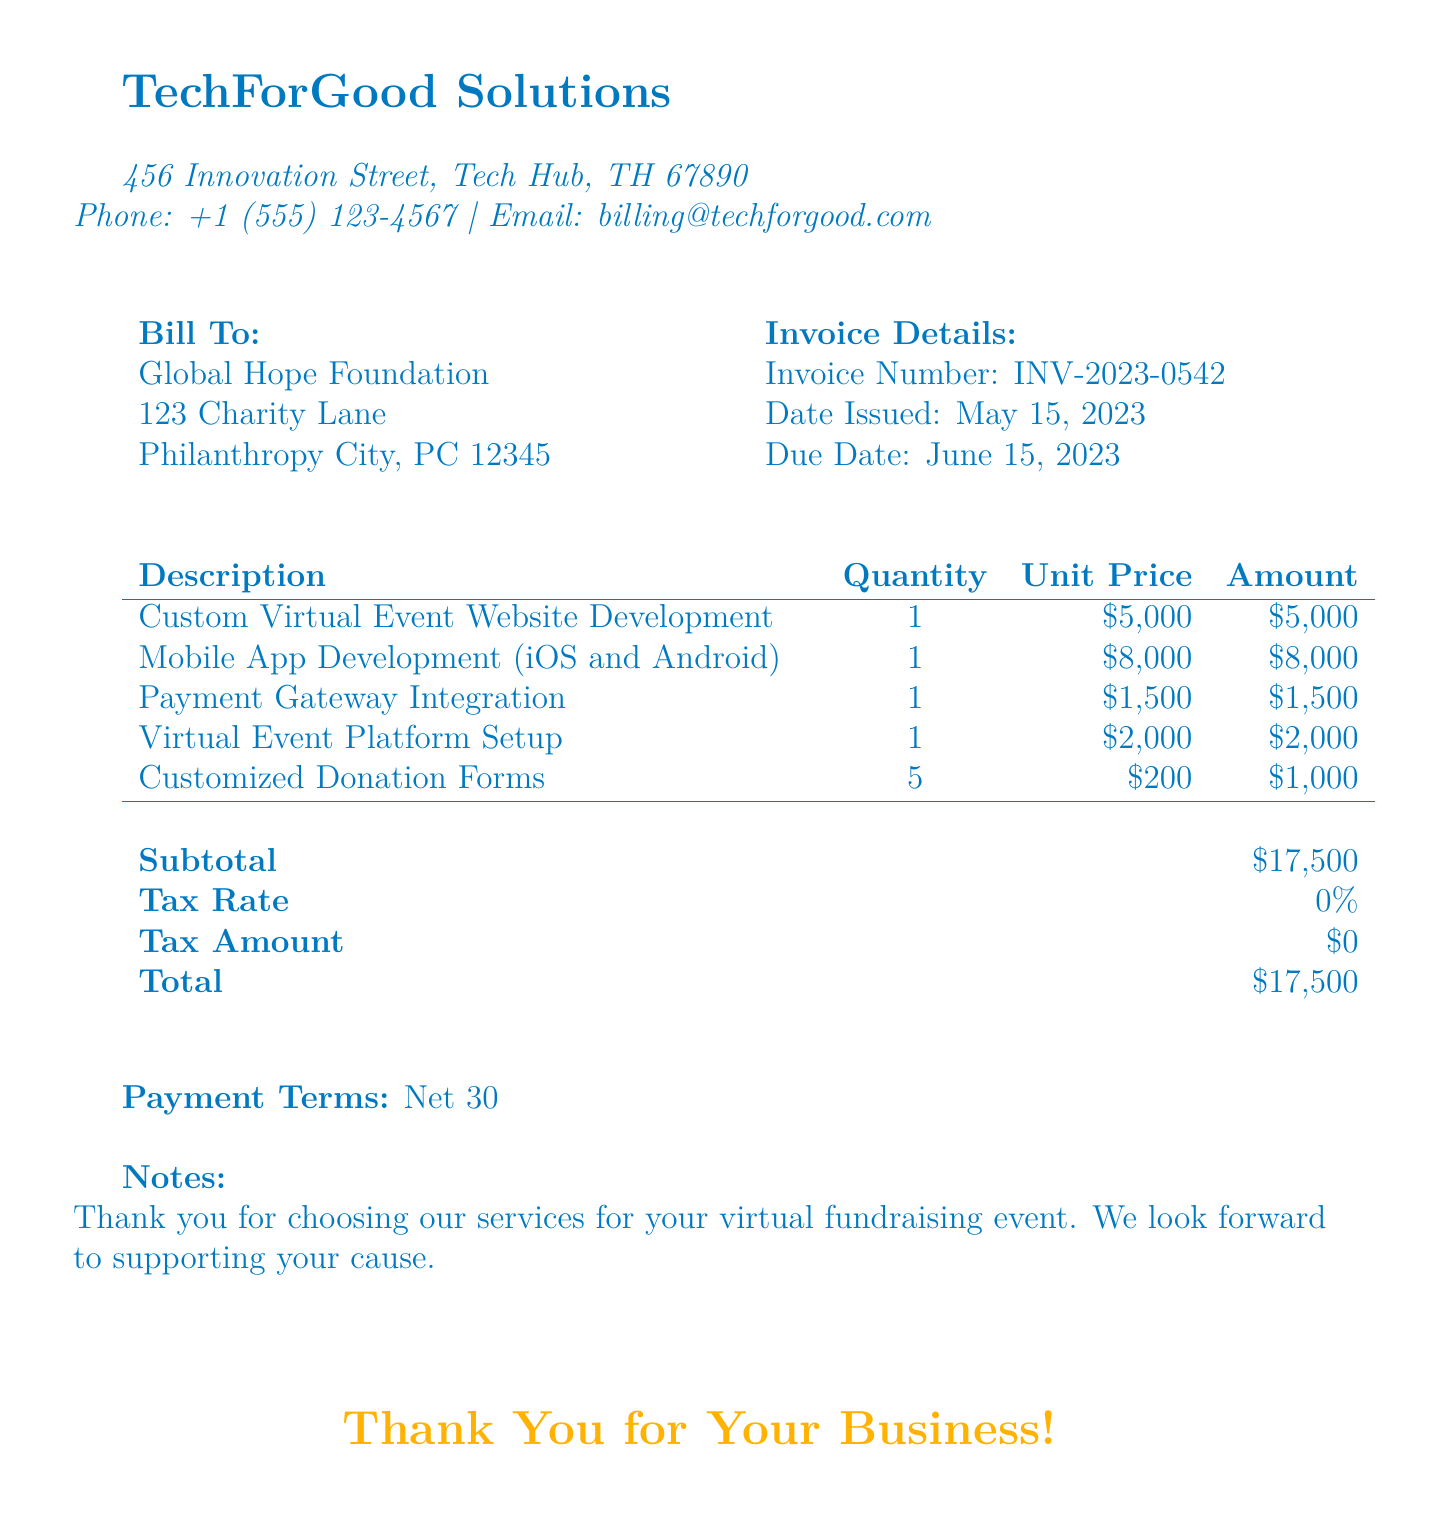What is the invoice number? The invoice number is a unique identifier for the bill, listed in the document.
Answer: INV-2023-0542 What is the date issued? The date issued refers to when the invoice was generated, and it is clearly stated in the document.
Answer: May 15, 2023 What is the total amount due? The total amount due is the grand total of all services and charges listed on the bill.
Answer: $17,500 How many customized donation forms are included? The quantity of customized donation forms is specified in the description section of the bill.
Answer: 5 What is the unit price of mobile app development? The unit price of mobile app development is stated alongside the description of that service.
Answer: $8,000 What is the subtotal before tax? The subtotal is the sum of all amounts before tax is applied, distinctly shown in the document.
Answer: $17,500 What are the payment terms? Payment terms specify the conditions under which the payment should be made, and are detailed in the invoice.
Answer: Net 30 What is the due date? The due date indicates when payment needs to be completed, which is explicitly provided in the document.
Answer: June 15, 2023 